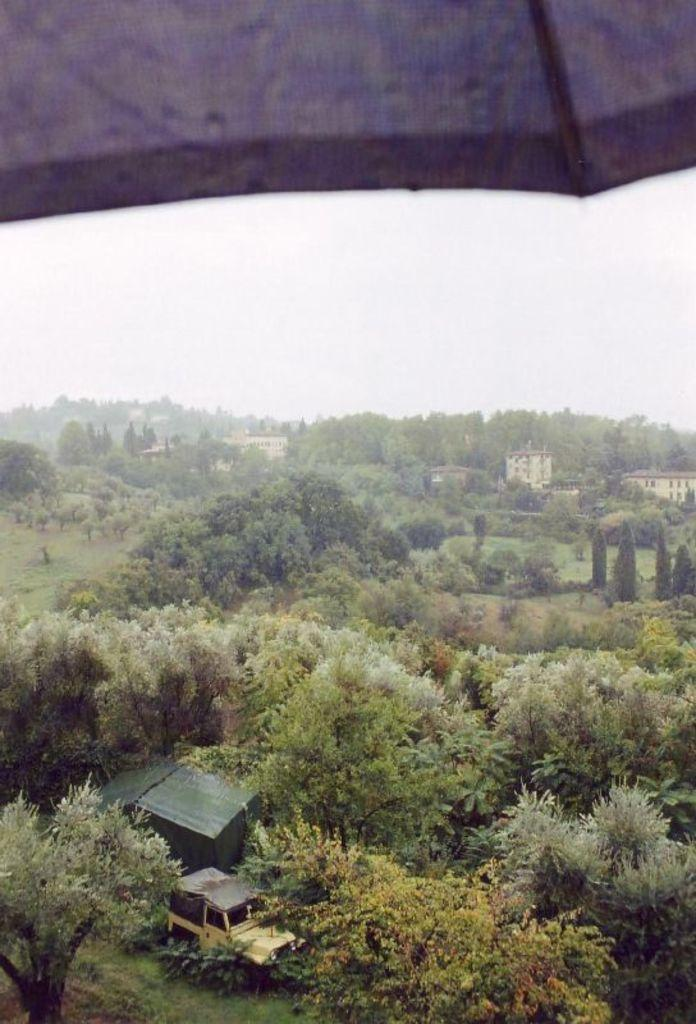What type of natural elements can be seen in the image? There are trees in the image. What man-made object is present in the image? There is a vehicle in the image. What structures can be seen in the background of the image? There are houses in the background of the image. What is visible in the sky in the image? The sky is clear and visible in the background of the image. How many lines can be seen on the hook in the image? There is no hook present in the image. What level of expertise does the beginner have in the image? There is no indication of any person's expertise or skill level in the image. 